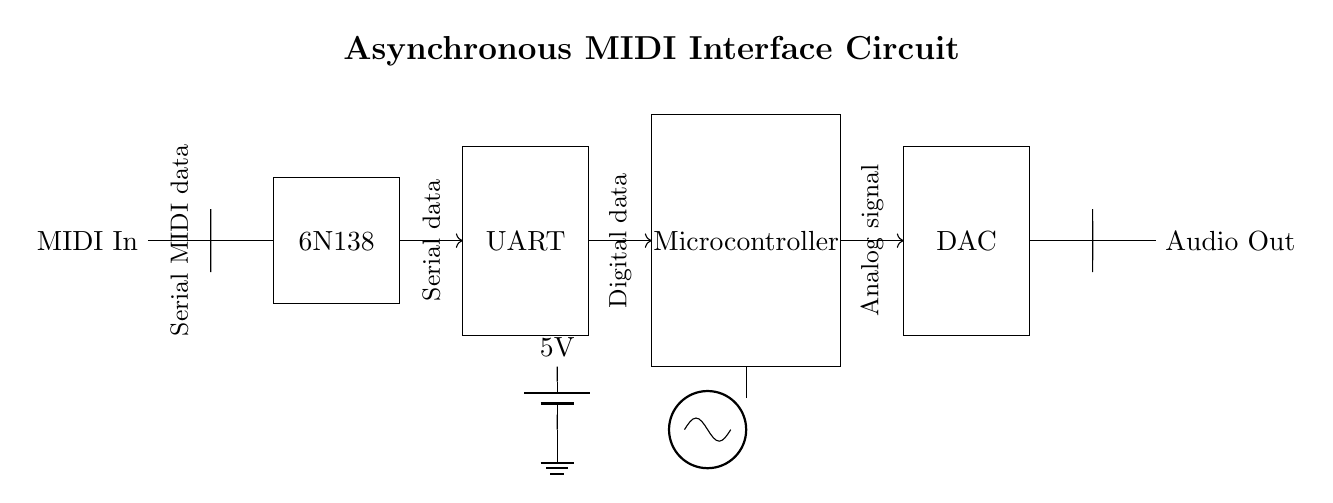What is the main component for MIDI signal isolation? The 6N138 is the optocoupler used for isolating MIDI signals, as it provides electrical isolation between the MIDI input and the rest of the circuit.
Answer: 6N138 What type of output does the DAC provide? The DAC converts digital data from the microcontroller into an analog signal output, which can be fed into the audio system.
Answer: Analog signal How many main components are in the circuit? There are five main components: MIDI In, 6N138, UART, microcontroller, and DAC.
Answer: Five What is the operating voltage for this circuit? The circuit operates at a voltage of 5 volts, indicated by the power supply shown in the diagram.
Answer: 5 volts What does the microcontroller do in this circuit? The microcontroller processes the digital data received from the UART and generates the appropriate signal to send to the DAC for audio output.
Answer: Processes digital data Which component acts as the interface between MIDI In and UART? The optocoupler (6N138) acts as the interface, providing signal isolation and allowing the MIDI data to interface with the UART safely.
Answer: Optocoupler How is the clock signal represented in the circuit? The clock signal is indicated by the oscillator symbol and is crucial for timing the data communication in the digital circuit.
Answer: Oscillator 